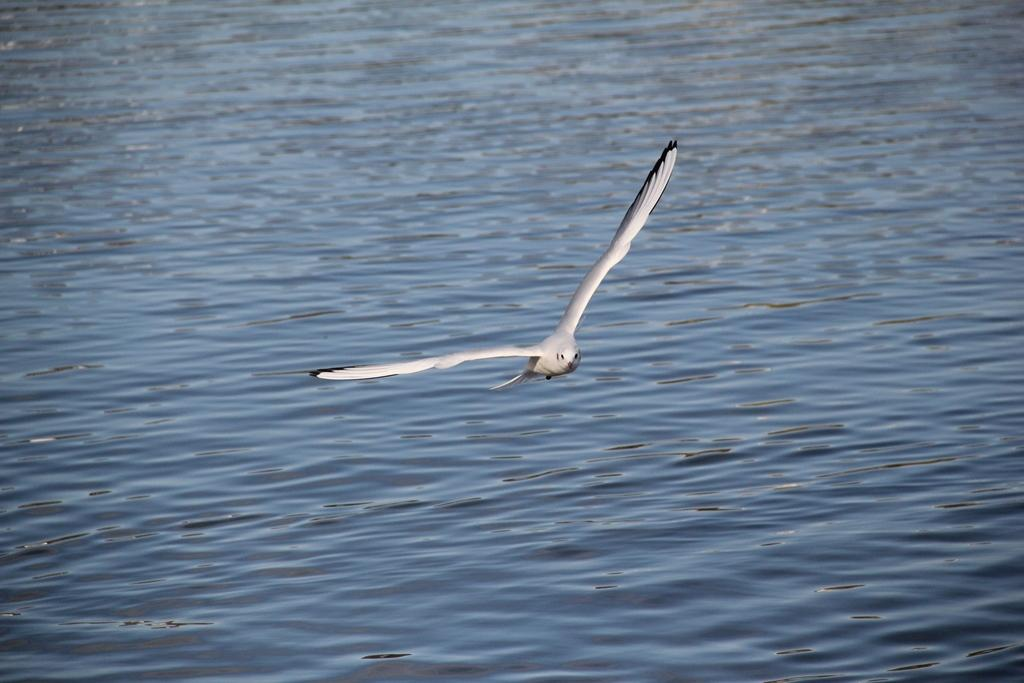What type of animal can be seen in the image? There is a bird in the image. What is visible in the background of the image? There is water visible in the background of the image. Can you tell me how many girls are exchanging headbands in the image? There are no girls or headbands present in the image; it features a bird and water in the background. 